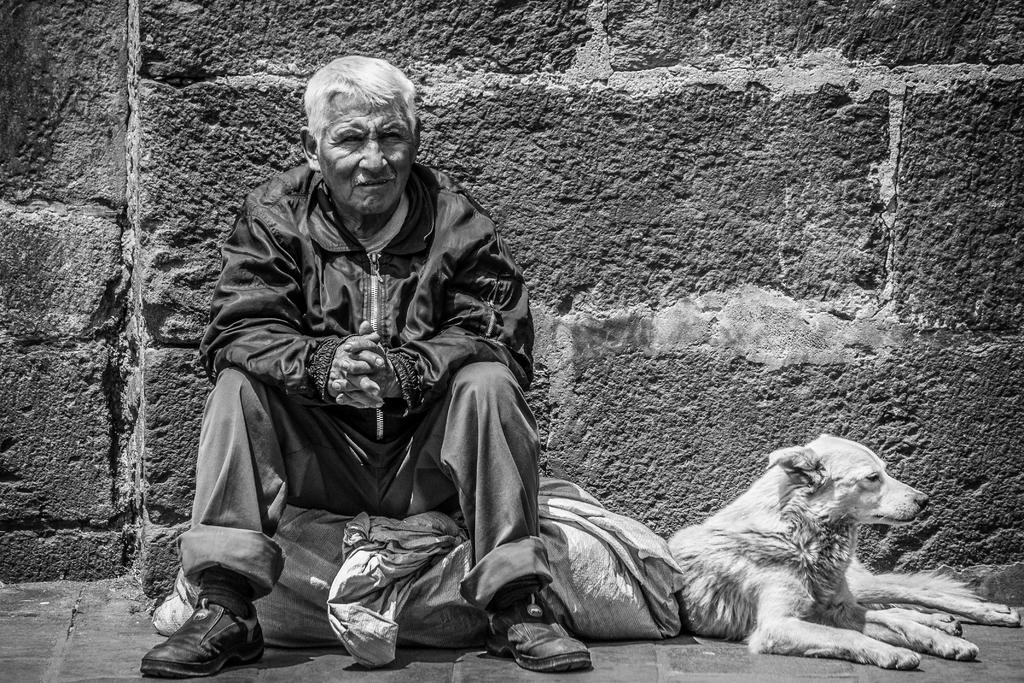What is the color scheme of the image? The image is black and white. Who or what can be seen in the image? There is a man and a dog in the image. What are the man and dog doing in the image? The man and dog are sitting. What object is present in the image? There is a sack in the image. What is the man wearing in the image? The man is wearing a jerkin, trousers, and shoes. What is the background of the image? There is a wall in the image. What is the man's tendency to stop wearing dresses in the image? There is no mention of dresses or the man's tendency to stop wearing them in the image. 